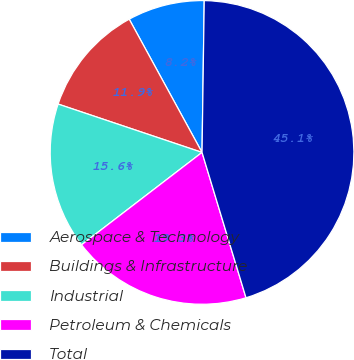Convert chart. <chart><loc_0><loc_0><loc_500><loc_500><pie_chart><fcel>Aerospace & Technology<fcel>Buildings & Infrastructure<fcel>Industrial<fcel>Petroleum & Chemicals<fcel>Total<nl><fcel>8.19%<fcel>11.88%<fcel>15.57%<fcel>19.26%<fcel>45.09%<nl></chart> 